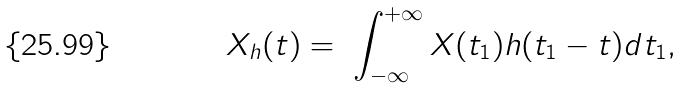<formula> <loc_0><loc_0><loc_500><loc_500>X _ { h } ( t ) = \ \int _ { - \infty } ^ { + \infty } X ( t _ { 1 } ) h ( t _ { 1 } - t ) d t _ { 1 } ,</formula> 